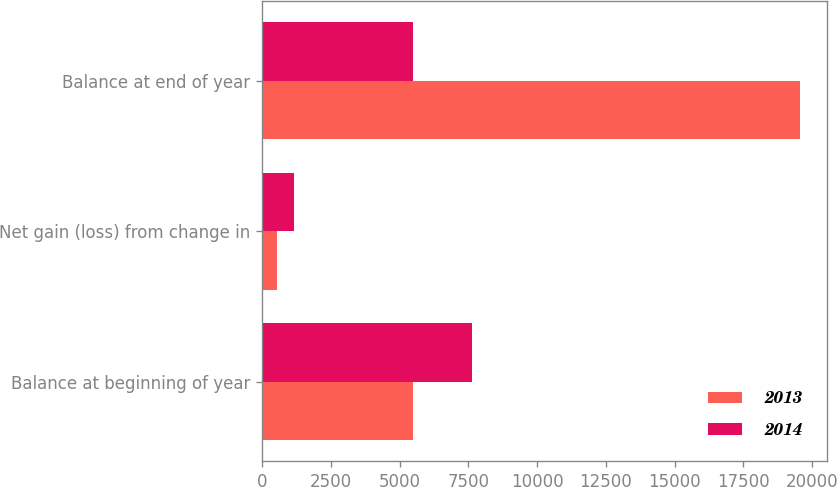<chart> <loc_0><loc_0><loc_500><loc_500><stacked_bar_chart><ecel><fcel>Balance at beginning of year<fcel>Net gain (loss) from change in<fcel>Balance at end of year<nl><fcel>2013<fcel>5484<fcel>553<fcel>19553<nl><fcel>2014<fcel>7618<fcel>1144<fcel>5484<nl></chart> 